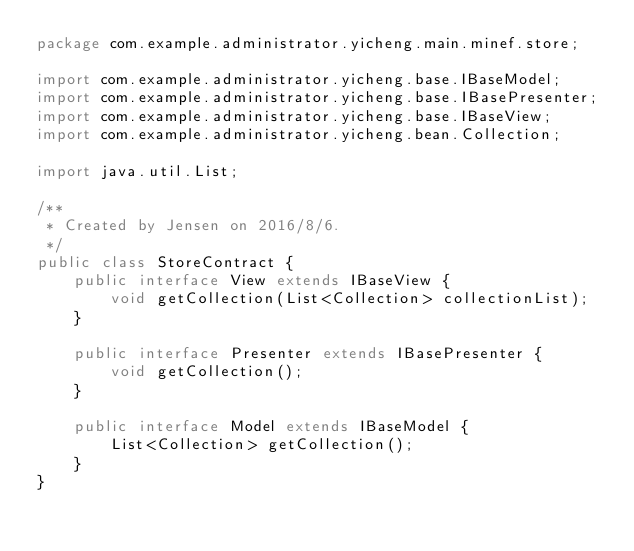Convert code to text. <code><loc_0><loc_0><loc_500><loc_500><_Java_>package com.example.administrator.yicheng.main.minef.store;

import com.example.administrator.yicheng.base.IBaseModel;
import com.example.administrator.yicheng.base.IBasePresenter;
import com.example.administrator.yicheng.base.IBaseView;
import com.example.administrator.yicheng.bean.Collection;

import java.util.List;

/**
 * Created by Jensen on 2016/8/6.
 */
public class StoreContract {
    public interface View extends IBaseView {
        void getCollection(List<Collection> collectionList);
    }

    public interface Presenter extends IBasePresenter {
        void getCollection();
    }

    public interface Model extends IBaseModel {
        List<Collection> getCollection();
    }
}
</code> 